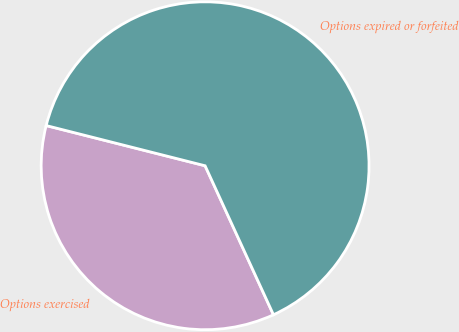Convert chart to OTSL. <chart><loc_0><loc_0><loc_500><loc_500><pie_chart><fcel>Options exercised<fcel>Options expired or forfeited<nl><fcel>35.79%<fcel>64.21%<nl></chart> 